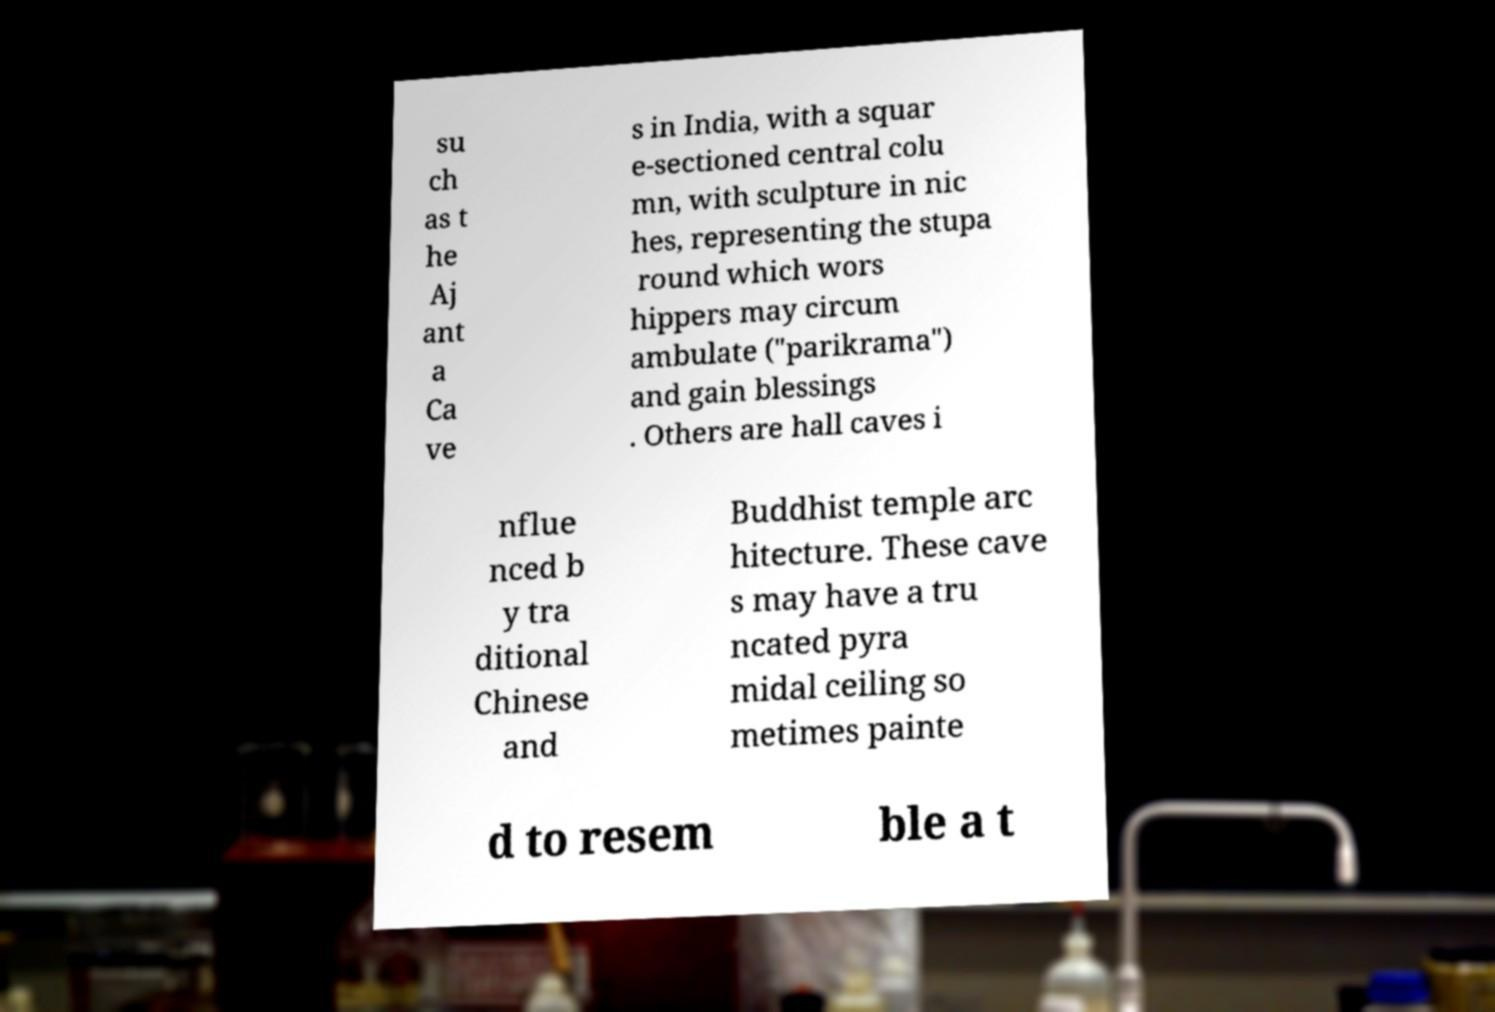Please identify and transcribe the text found in this image. su ch as t he Aj ant a Ca ve s in India, with a squar e-sectioned central colu mn, with sculpture in nic hes, representing the stupa round which wors hippers may circum ambulate ("parikrama") and gain blessings . Others are hall caves i nflue nced b y tra ditional Chinese and Buddhist temple arc hitecture. These cave s may have a tru ncated pyra midal ceiling so metimes painte d to resem ble a t 